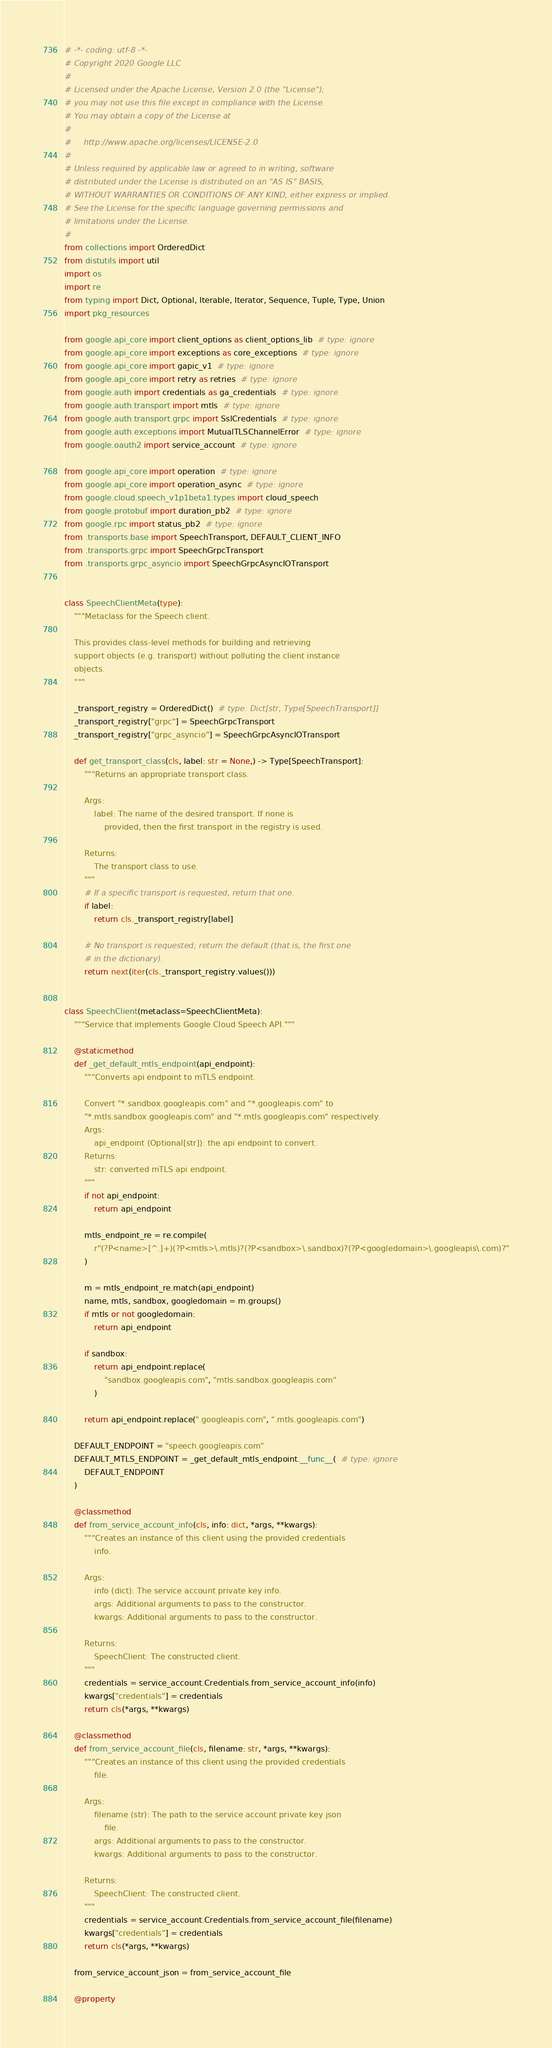<code> <loc_0><loc_0><loc_500><loc_500><_Python_># -*- coding: utf-8 -*-
# Copyright 2020 Google LLC
#
# Licensed under the Apache License, Version 2.0 (the "License");
# you may not use this file except in compliance with the License.
# You may obtain a copy of the License at
#
#     http://www.apache.org/licenses/LICENSE-2.0
#
# Unless required by applicable law or agreed to in writing, software
# distributed under the License is distributed on an "AS IS" BASIS,
# WITHOUT WARRANTIES OR CONDITIONS OF ANY KIND, either express or implied.
# See the License for the specific language governing permissions and
# limitations under the License.
#
from collections import OrderedDict
from distutils import util
import os
import re
from typing import Dict, Optional, Iterable, Iterator, Sequence, Tuple, Type, Union
import pkg_resources

from google.api_core import client_options as client_options_lib  # type: ignore
from google.api_core import exceptions as core_exceptions  # type: ignore
from google.api_core import gapic_v1  # type: ignore
from google.api_core import retry as retries  # type: ignore
from google.auth import credentials as ga_credentials  # type: ignore
from google.auth.transport import mtls  # type: ignore
from google.auth.transport.grpc import SslCredentials  # type: ignore
from google.auth.exceptions import MutualTLSChannelError  # type: ignore
from google.oauth2 import service_account  # type: ignore

from google.api_core import operation  # type: ignore
from google.api_core import operation_async  # type: ignore
from google.cloud.speech_v1p1beta1.types import cloud_speech
from google.protobuf import duration_pb2  # type: ignore
from google.rpc import status_pb2  # type: ignore
from .transports.base import SpeechTransport, DEFAULT_CLIENT_INFO
from .transports.grpc import SpeechGrpcTransport
from .transports.grpc_asyncio import SpeechGrpcAsyncIOTransport


class SpeechClientMeta(type):
    """Metaclass for the Speech client.

    This provides class-level methods for building and retrieving
    support objects (e.g. transport) without polluting the client instance
    objects.
    """

    _transport_registry = OrderedDict()  # type: Dict[str, Type[SpeechTransport]]
    _transport_registry["grpc"] = SpeechGrpcTransport
    _transport_registry["grpc_asyncio"] = SpeechGrpcAsyncIOTransport

    def get_transport_class(cls, label: str = None,) -> Type[SpeechTransport]:
        """Returns an appropriate transport class.

        Args:
            label: The name of the desired transport. If none is
                provided, then the first transport in the registry is used.

        Returns:
            The transport class to use.
        """
        # If a specific transport is requested, return that one.
        if label:
            return cls._transport_registry[label]

        # No transport is requested; return the default (that is, the first one
        # in the dictionary).
        return next(iter(cls._transport_registry.values()))


class SpeechClient(metaclass=SpeechClientMeta):
    """Service that implements Google Cloud Speech API."""

    @staticmethod
    def _get_default_mtls_endpoint(api_endpoint):
        """Converts api endpoint to mTLS endpoint.

        Convert "*.sandbox.googleapis.com" and "*.googleapis.com" to
        "*.mtls.sandbox.googleapis.com" and "*.mtls.googleapis.com" respectively.
        Args:
            api_endpoint (Optional[str]): the api endpoint to convert.
        Returns:
            str: converted mTLS api endpoint.
        """
        if not api_endpoint:
            return api_endpoint

        mtls_endpoint_re = re.compile(
            r"(?P<name>[^.]+)(?P<mtls>\.mtls)?(?P<sandbox>\.sandbox)?(?P<googledomain>\.googleapis\.com)?"
        )

        m = mtls_endpoint_re.match(api_endpoint)
        name, mtls, sandbox, googledomain = m.groups()
        if mtls or not googledomain:
            return api_endpoint

        if sandbox:
            return api_endpoint.replace(
                "sandbox.googleapis.com", "mtls.sandbox.googleapis.com"
            )

        return api_endpoint.replace(".googleapis.com", ".mtls.googleapis.com")

    DEFAULT_ENDPOINT = "speech.googleapis.com"
    DEFAULT_MTLS_ENDPOINT = _get_default_mtls_endpoint.__func__(  # type: ignore
        DEFAULT_ENDPOINT
    )

    @classmethod
    def from_service_account_info(cls, info: dict, *args, **kwargs):
        """Creates an instance of this client using the provided credentials
            info.

        Args:
            info (dict): The service account private key info.
            args: Additional arguments to pass to the constructor.
            kwargs: Additional arguments to pass to the constructor.

        Returns:
            SpeechClient: The constructed client.
        """
        credentials = service_account.Credentials.from_service_account_info(info)
        kwargs["credentials"] = credentials
        return cls(*args, **kwargs)

    @classmethod
    def from_service_account_file(cls, filename: str, *args, **kwargs):
        """Creates an instance of this client using the provided credentials
            file.

        Args:
            filename (str): The path to the service account private key json
                file.
            args: Additional arguments to pass to the constructor.
            kwargs: Additional arguments to pass to the constructor.

        Returns:
            SpeechClient: The constructed client.
        """
        credentials = service_account.Credentials.from_service_account_file(filename)
        kwargs["credentials"] = credentials
        return cls(*args, **kwargs)

    from_service_account_json = from_service_account_file

    @property</code> 